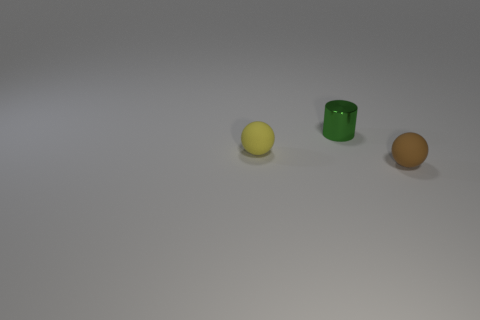What number of other objects are there of the same color as the small cylinder?
Give a very brief answer. 0. There is a yellow matte thing in front of the green metal thing; does it have the same shape as the matte object that is right of the metal object?
Provide a short and direct response. Yes. What number of other objects are the same material as the brown ball?
Offer a very short reply. 1. Is there a sphere in front of the sphere that is on the right side of the tiny rubber ball that is to the left of the small metallic cylinder?
Give a very brief answer. No. Do the tiny brown sphere and the green thing have the same material?
Make the answer very short. No. Is there anything else that is the same shape as the brown thing?
Ensure brevity in your answer.  Yes. What is the material of the sphere to the left of the small rubber ball that is on the right side of the green object?
Make the answer very short. Rubber. How big is the sphere on the right side of the shiny thing?
Make the answer very short. Small. There is a small thing that is both in front of the tiny green shiny thing and behind the brown ball; what is its color?
Offer a very short reply. Yellow. Does the green cylinder that is right of the yellow matte object have the same size as the yellow matte object?
Keep it short and to the point. Yes. 